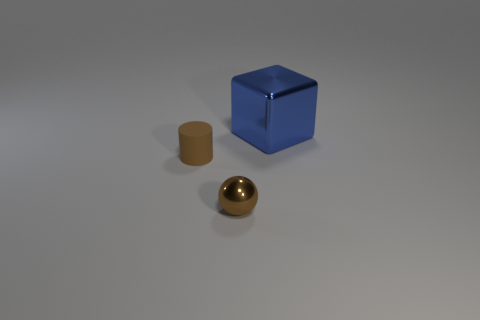Add 1 small cylinders. How many objects exist? 4 Subtract all balls. How many objects are left? 2 Subtract all rubber things. Subtract all brown rubber objects. How many objects are left? 1 Add 2 cylinders. How many cylinders are left? 3 Add 3 balls. How many balls exist? 4 Subtract 0 red balls. How many objects are left? 3 